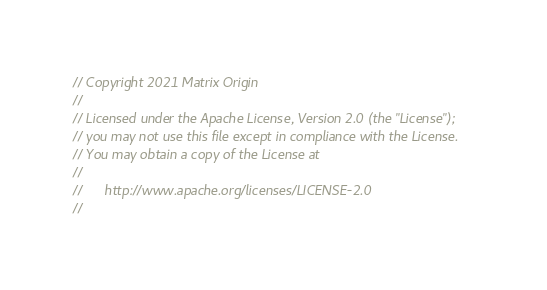Convert code to text. <code><loc_0><loc_0><loc_500><loc_500><_Go_>// Copyright 2021 Matrix Origin
//
// Licensed under the Apache License, Version 2.0 (the "License");
// you may not use this file except in compliance with the License.
// You may obtain a copy of the License at
//
//      http://www.apache.org/licenses/LICENSE-2.0
//</code> 